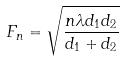Convert formula to latex. <formula><loc_0><loc_0><loc_500><loc_500>F _ { n } = \sqrt { \frac { n \lambda d _ { 1 } d _ { 2 } } { d _ { 1 } + d _ { 2 } } }</formula> 